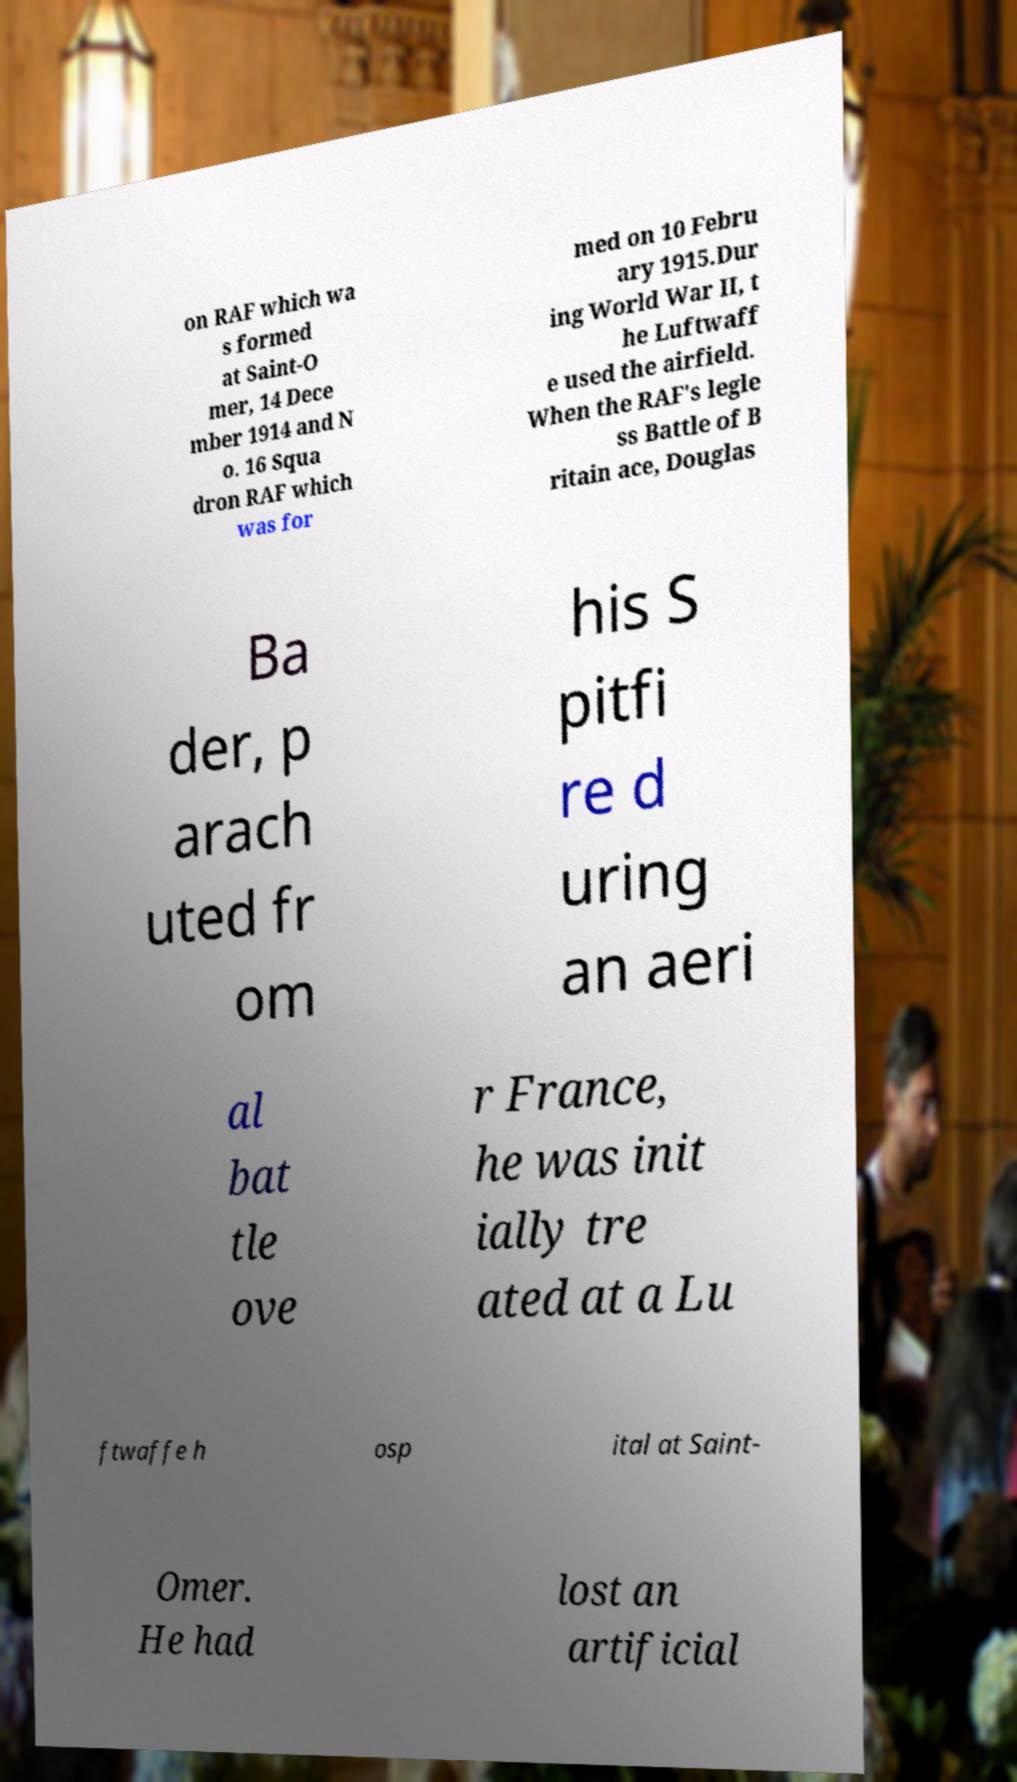There's text embedded in this image that I need extracted. Can you transcribe it verbatim? on RAF which wa s formed at Saint-O mer, 14 Dece mber 1914 and N o. 16 Squa dron RAF which was for med on 10 Febru ary 1915.Dur ing World War II, t he Luftwaff e used the airfield. When the RAF's legle ss Battle of B ritain ace, Douglas Ba der, p arach uted fr om his S pitfi re d uring an aeri al bat tle ove r France, he was init ially tre ated at a Lu ftwaffe h osp ital at Saint- Omer. He had lost an artificial 